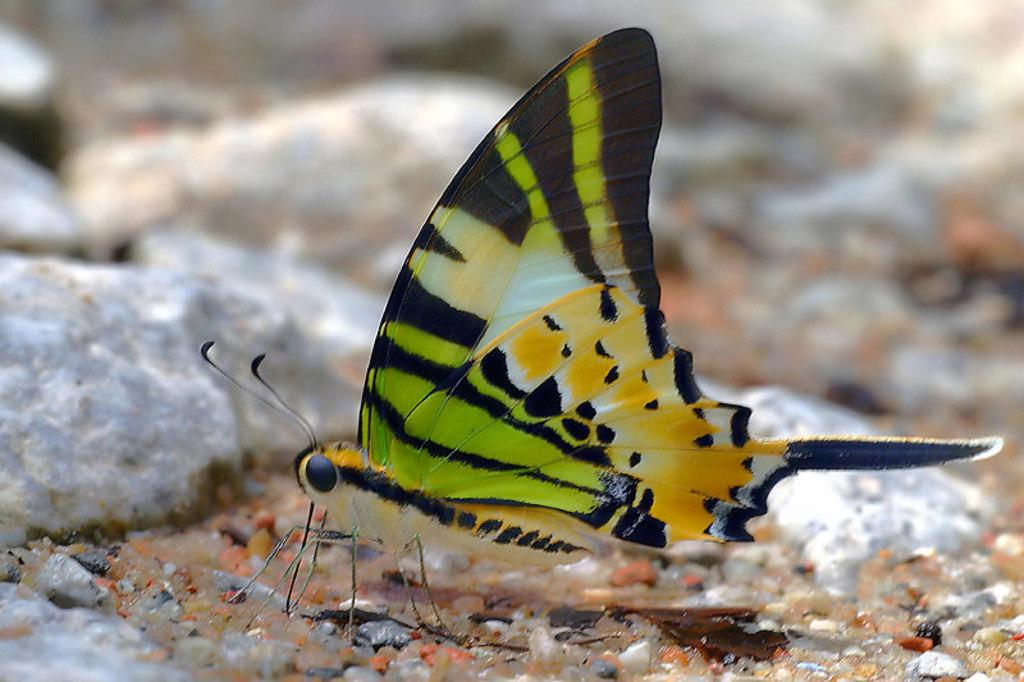What type of creature is in the image? There is a butterfly in the image. What colors can be seen on the butterfly? The butterfly has black, green, white, and orange colors. How is the background of the butterfly depicted in the image? The background of the butterfly is blurred. What can be observed about the other elements in the image? There are colorful things in the image. What type of liquid is being poured from the bead in the image? There is no bead or liquid present in the image; it features a butterfly with a blurred background and colorful elements. 